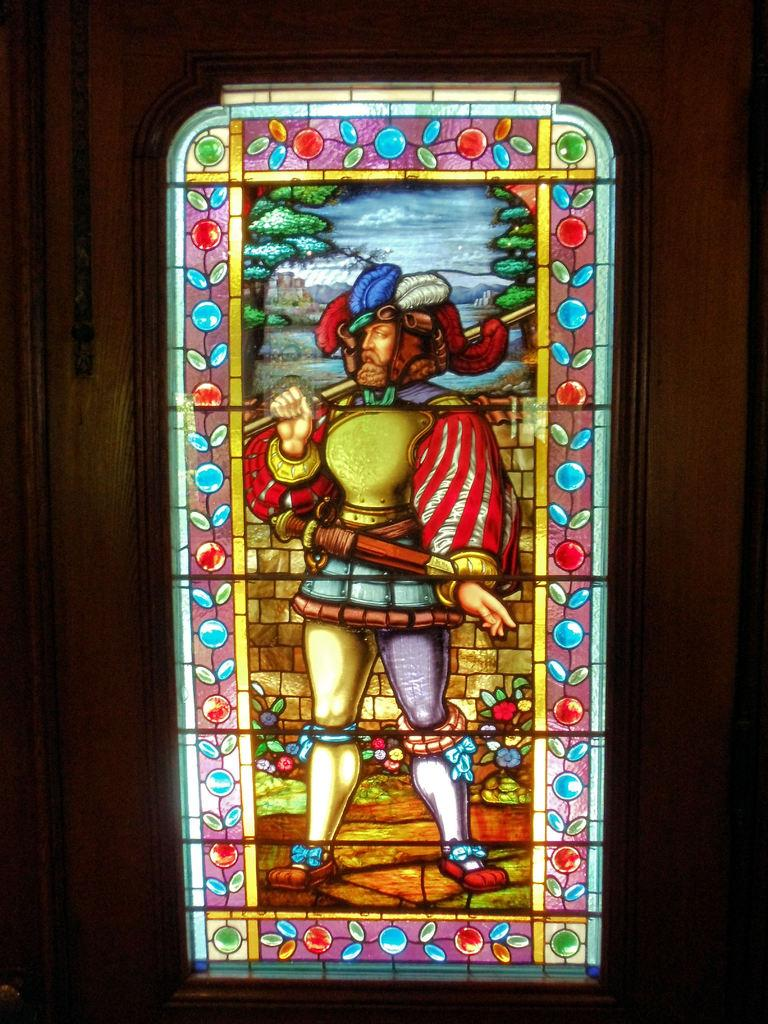What is located in the center of the image? There is a wall in the center of the image. What material is present in the image? There is glass in the image. What is the person in the image doing? A person is standing on the glass. What is the person holding in the image? The person is holding an object. Can you describe the design on the glass? There is a design on the glass. How many rings does the wren have on its leg in the image? There is no wren present in the image, and therefore no rings on its leg. 